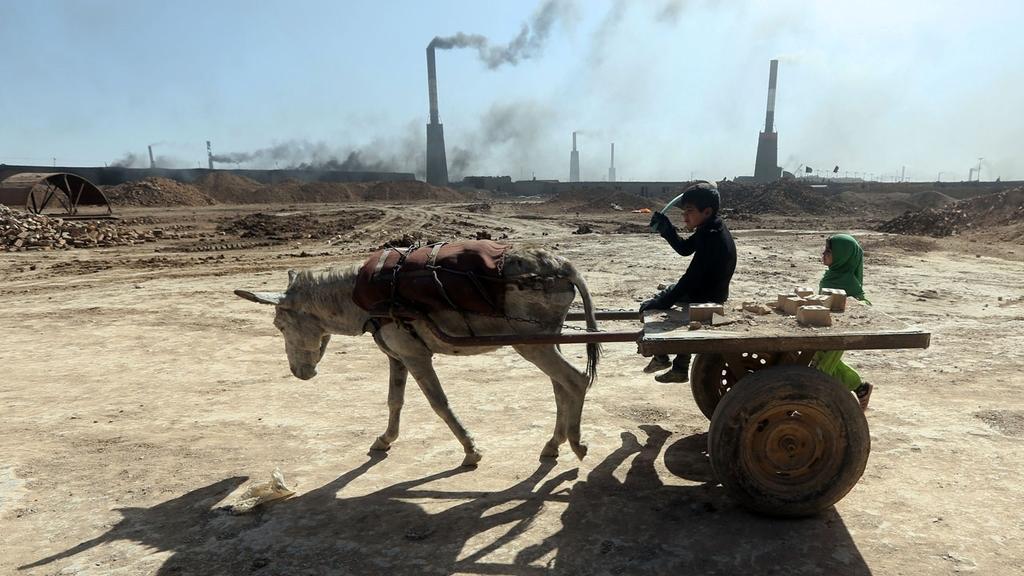Can you describe this image briefly? In this image I can see the ground, an animal and a cart attached to it. I can see a person is sitting on the cart and a person is standing on the ground. In the background I can see few poles, smoke coming from them and the sky. 